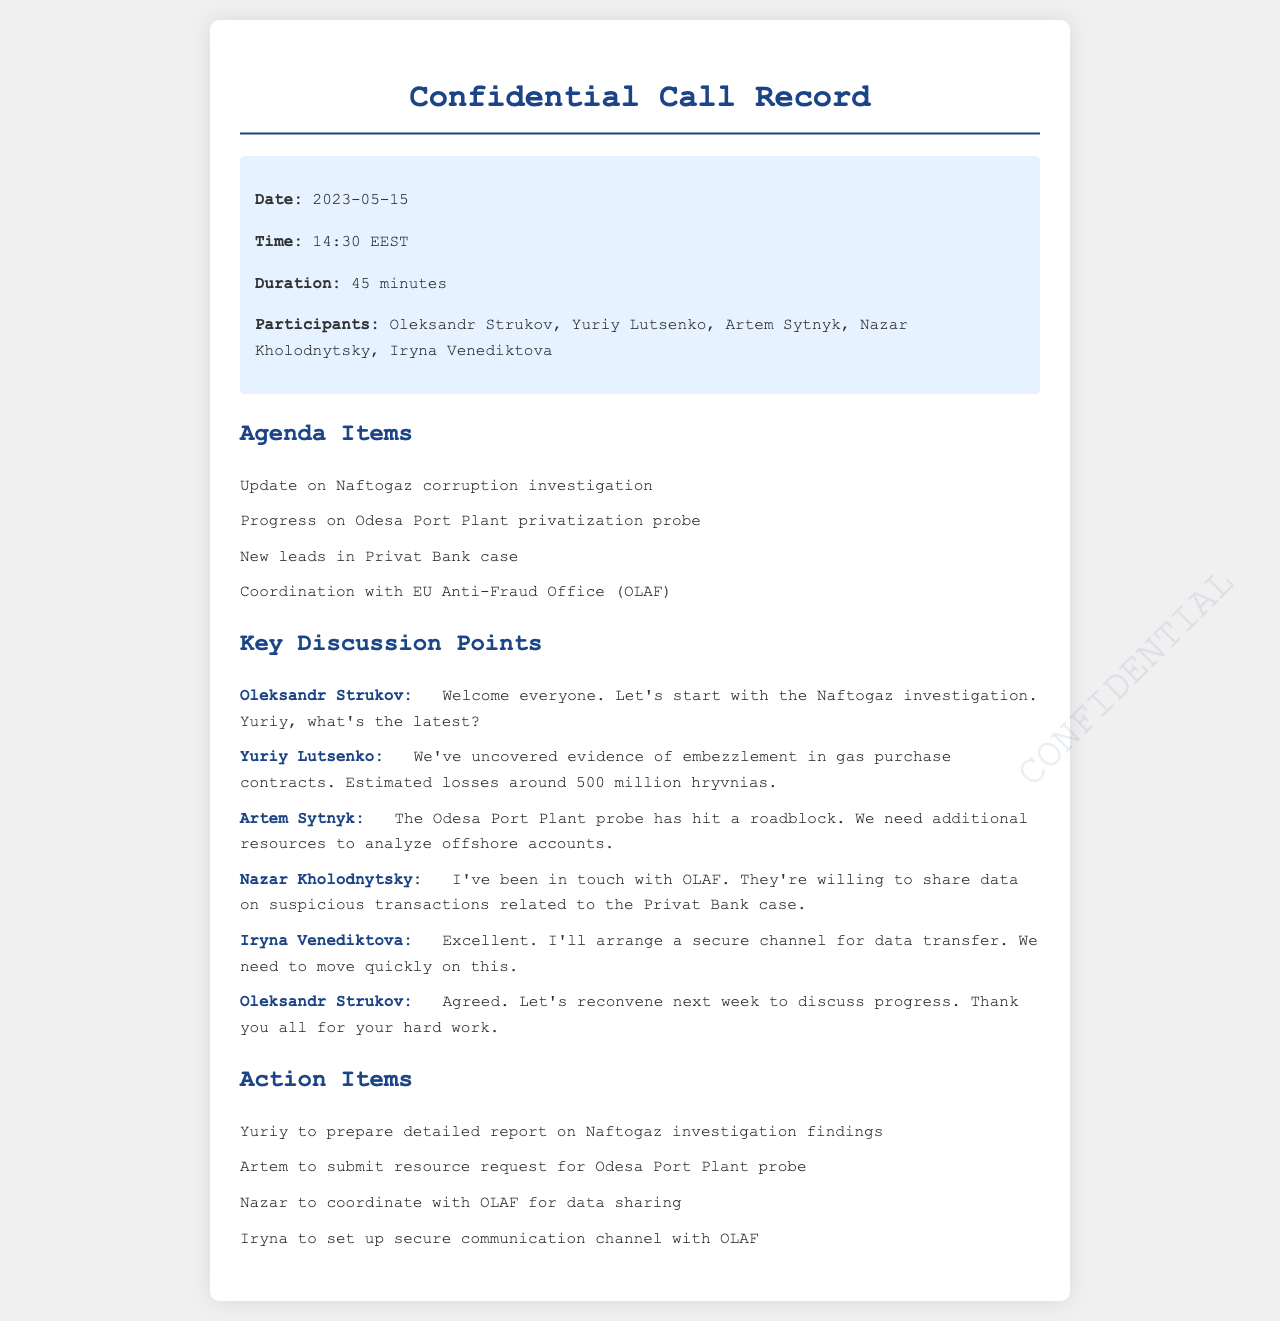what was the date of the conference call? The date of the conference call is explicitly stated in the call details section of the document.
Answer: 2023-05-15 who mentioned the evidence of embezzlement in gas purchase contracts? This information is found in the discussion section, where the speaker identifies themselves while sharing the findings.
Answer: Yuriy Lutsenko how much were the estimated losses in the Naftogaz investigation? The estimated losses number is mentioned directly in the points discussed during the call.
Answer: 500 million hryvnias what was the main issue with the Odesa Port Plant probe? This issue is highlighted in the discussion by one of the participants regarding the resources needed for analysis.
Answer: Roadblock who is responsible for coordinating with OLAF for data sharing? The action items section of the document states clearly who is tasked with this responsibility.
Answer: Nazar when will the team reconvene to discuss progress? The timing for the next meeting is mentioned in the concluding remarks of one of the participants.
Answer: Next week what is the total duration of the call? This information is found in the call details section, indicating how long the call lasted.
Answer: 45 minutes who is tasked with preparing a detailed report on Naftogaz findings? This is explicitly stated in the action items, identifying who has the specific responsibility.
Answer: Yuriy what is the purpose of setting up a secure channel? The purpose is inferred from the context of the discussion about data transfer needs.
Answer: Data transfer 